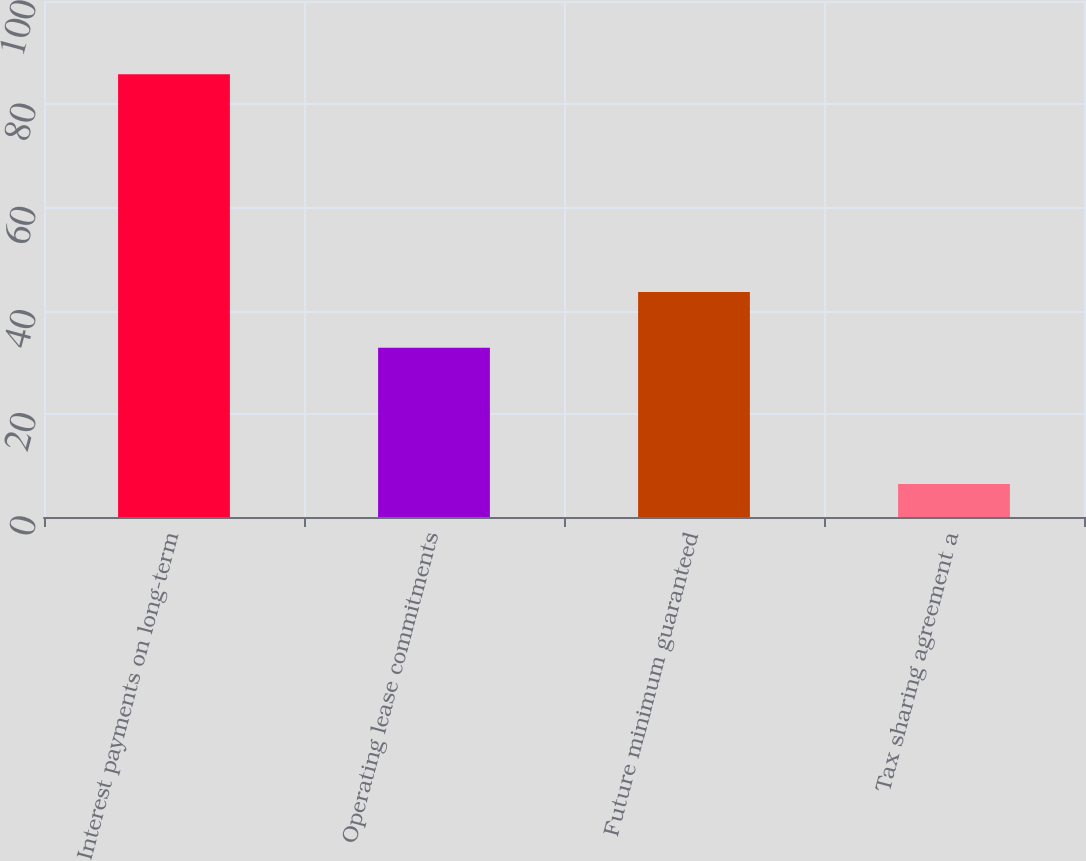Convert chart to OTSL. <chart><loc_0><loc_0><loc_500><loc_500><bar_chart><fcel>Interest payments on long-term<fcel>Operating lease commitments<fcel>Future minimum guaranteed<fcel>Tax sharing agreement a<nl><fcel>85.8<fcel>32.8<fcel>43.6<fcel>6.4<nl></chart> 